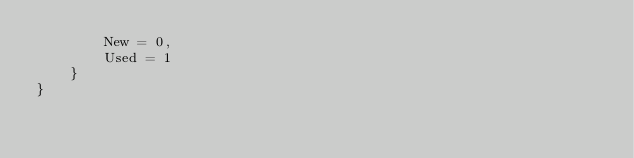<code> <loc_0><loc_0><loc_500><loc_500><_C#_>        New = 0,
        Used = 1
    }
}</code> 